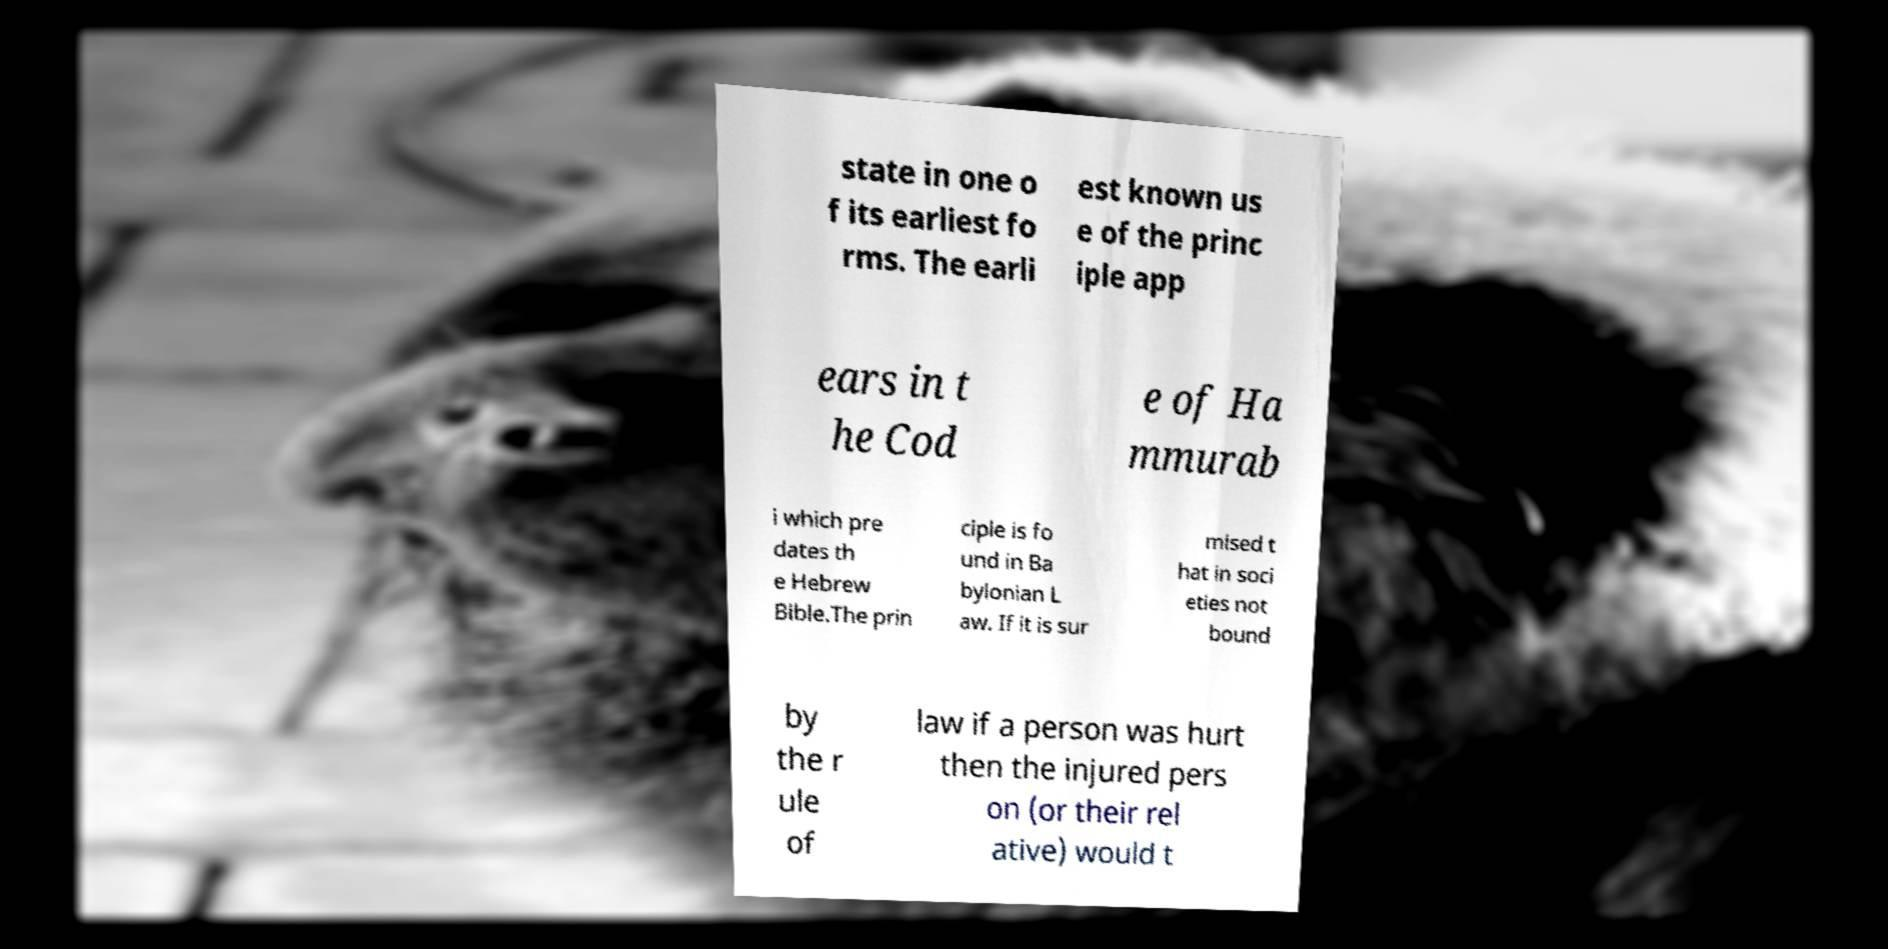What messages or text are displayed in this image? I need them in a readable, typed format. state in one o f its earliest fo rms. The earli est known us e of the princ iple app ears in t he Cod e of Ha mmurab i which pre dates th e Hebrew Bible.The prin ciple is fo und in Ba bylonian L aw. If it is sur mised t hat in soci eties not bound by the r ule of law if a person was hurt then the injured pers on (or their rel ative) would t 